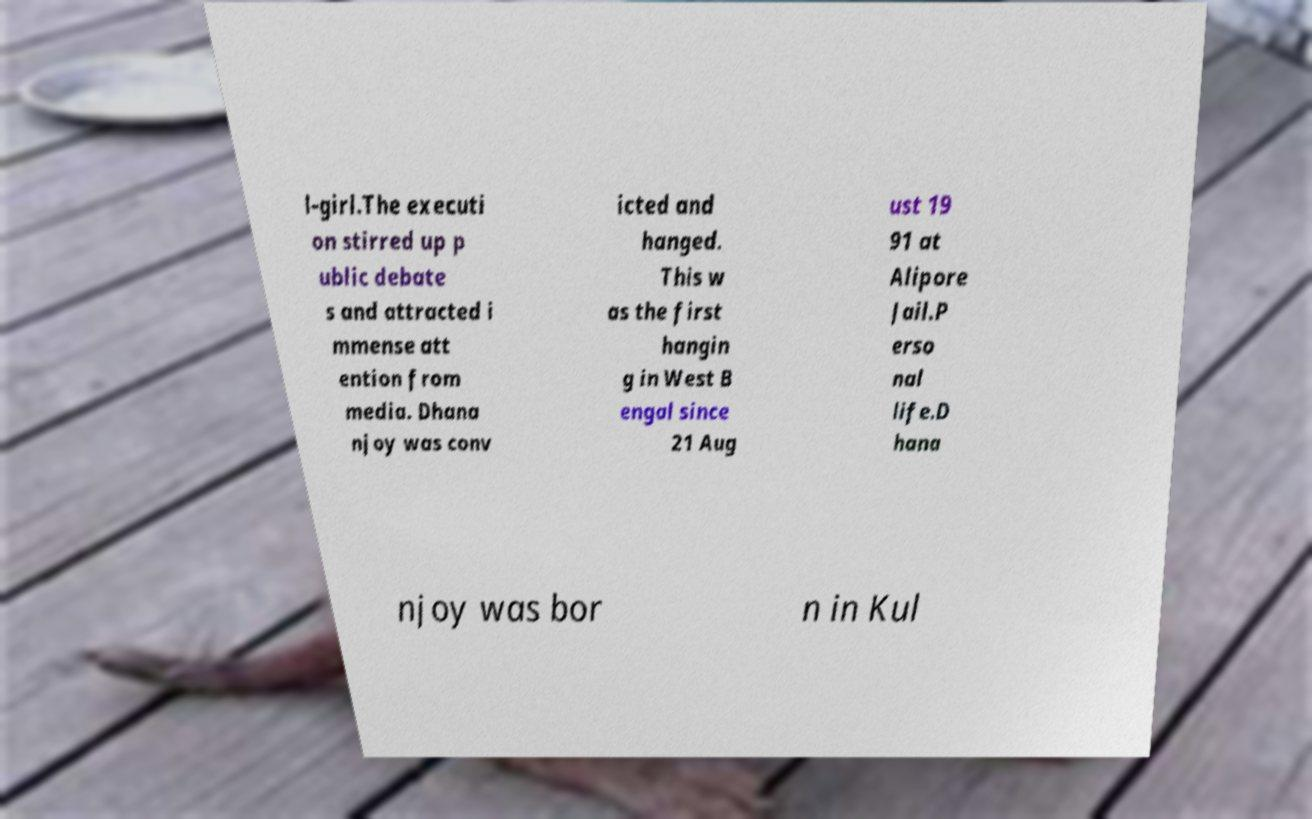Please identify and transcribe the text found in this image. l-girl.The executi on stirred up p ublic debate s and attracted i mmense att ention from media. Dhana njoy was conv icted and hanged. This w as the first hangin g in West B engal since 21 Aug ust 19 91 at Alipore Jail.P erso nal life.D hana njoy was bor n in Kul 